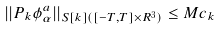<formula> <loc_0><loc_0><loc_500><loc_500>| | P _ { k } \phi ^ { a } _ { \alpha } | | _ { S [ k ] ( [ - T , T ] \times R ^ { 3 } ) } \leq M c _ { k }</formula> 